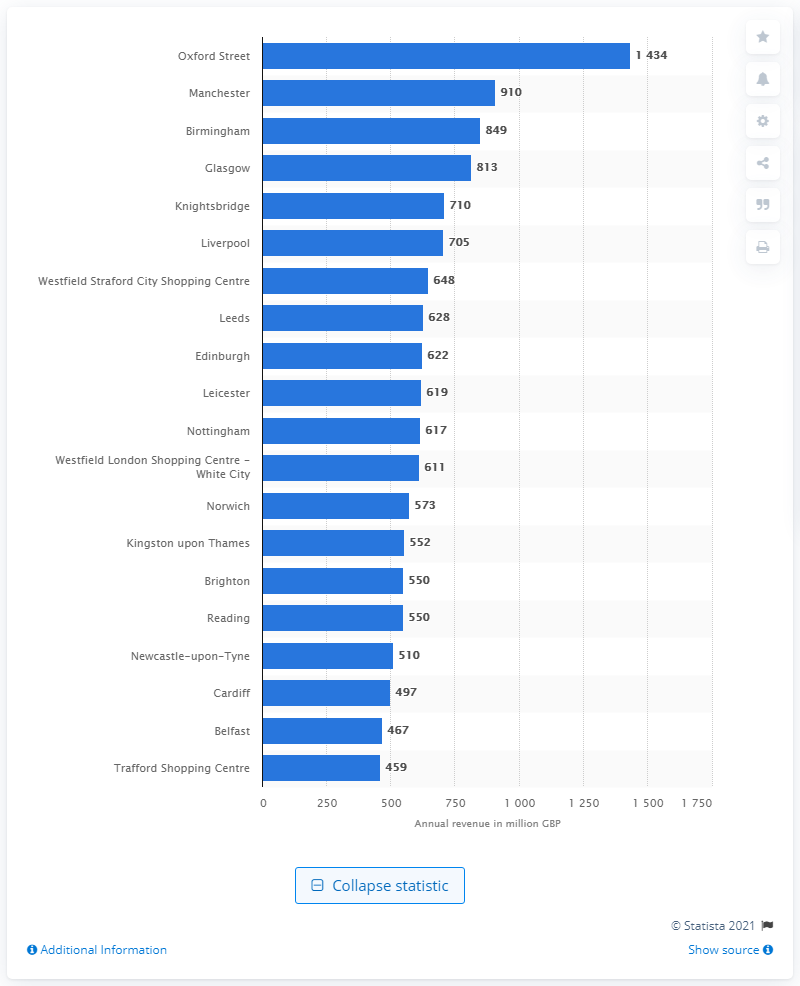Give some essential details in this illustration. In 2014, Oxford Street was ranked as the highest retail center in the UK. Oxford Street's annual revenue in 2014 was approximately 1,434. 